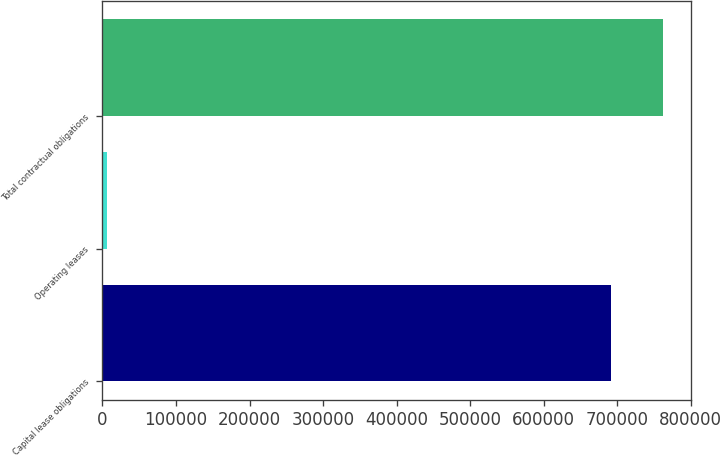Convert chart to OTSL. <chart><loc_0><loc_0><loc_500><loc_500><bar_chart><fcel>Capital lease obligations<fcel>Operating leases<fcel>Total contractual obligations<nl><fcel>691644<fcel>6104<fcel>761979<nl></chart> 